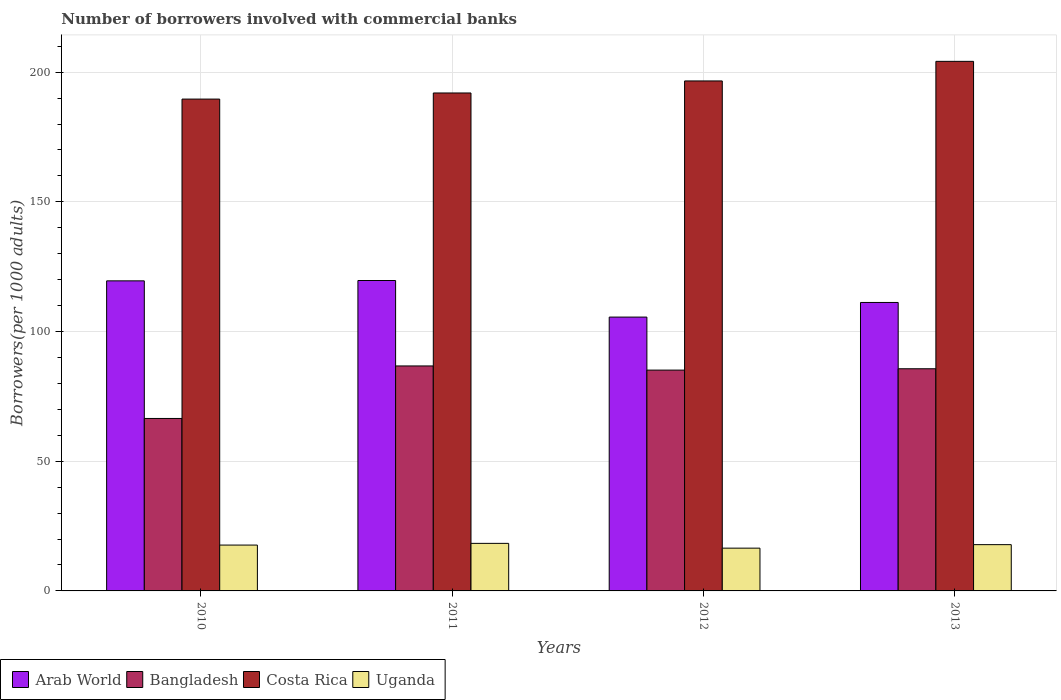How many different coloured bars are there?
Your response must be concise. 4. Are the number of bars on each tick of the X-axis equal?
Your answer should be compact. Yes. How many bars are there on the 3rd tick from the left?
Give a very brief answer. 4. How many bars are there on the 4th tick from the right?
Provide a short and direct response. 4. What is the number of borrowers involved with commercial banks in Bangladesh in 2011?
Provide a short and direct response. 86.74. Across all years, what is the maximum number of borrowers involved with commercial banks in Costa Rica?
Offer a very short reply. 204.18. Across all years, what is the minimum number of borrowers involved with commercial banks in Bangladesh?
Make the answer very short. 66.49. In which year was the number of borrowers involved with commercial banks in Arab World maximum?
Make the answer very short. 2011. What is the total number of borrowers involved with commercial banks in Uganda in the graph?
Give a very brief answer. 70.34. What is the difference between the number of borrowers involved with commercial banks in Bangladesh in 2010 and that in 2013?
Provide a short and direct response. -19.16. What is the difference between the number of borrowers involved with commercial banks in Arab World in 2012 and the number of borrowers involved with commercial banks in Uganda in 2013?
Offer a terse response. 87.74. What is the average number of borrowers involved with commercial banks in Bangladesh per year?
Offer a terse response. 81.01. In the year 2010, what is the difference between the number of borrowers involved with commercial banks in Costa Rica and number of borrowers involved with commercial banks in Arab World?
Provide a succinct answer. 70.08. In how many years, is the number of borrowers involved with commercial banks in Bangladesh greater than 110?
Give a very brief answer. 0. What is the ratio of the number of borrowers involved with commercial banks in Uganda in 2010 to that in 2011?
Your response must be concise. 0.96. What is the difference between the highest and the second highest number of borrowers involved with commercial banks in Costa Rica?
Your answer should be compact. 7.55. What is the difference between the highest and the lowest number of borrowers involved with commercial banks in Costa Rica?
Your response must be concise. 14.55. In how many years, is the number of borrowers involved with commercial banks in Uganda greater than the average number of borrowers involved with commercial banks in Uganda taken over all years?
Keep it short and to the point. 3. Is the sum of the number of borrowers involved with commercial banks in Bangladesh in 2012 and 2013 greater than the maximum number of borrowers involved with commercial banks in Costa Rica across all years?
Your answer should be very brief. No. What does the 2nd bar from the left in 2011 represents?
Make the answer very short. Bangladesh. What does the 1st bar from the right in 2010 represents?
Offer a terse response. Uganda. Is it the case that in every year, the sum of the number of borrowers involved with commercial banks in Arab World and number of borrowers involved with commercial banks in Bangladesh is greater than the number of borrowers involved with commercial banks in Uganda?
Provide a succinct answer. Yes. How many bars are there?
Offer a very short reply. 16. Are all the bars in the graph horizontal?
Provide a short and direct response. No. Are the values on the major ticks of Y-axis written in scientific E-notation?
Your response must be concise. No. Does the graph contain grids?
Offer a terse response. Yes. Where does the legend appear in the graph?
Your answer should be very brief. Bottom left. What is the title of the graph?
Make the answer very short. Number of borrowers involved with commercial banks. What is the label or title of the X-axis?
Provide a succinct answer. Years. What is the label or title of the Y-axis?
Make the answer very short. Borrowers(per 1000 adults). What is the Borrowers(per 1000 adults) in Arab World in 2010?
Ensure brevity in your answer.  119.55. What is the Borrowers(per 1000 adults) of Bangladesh in 2010?
Your response must be concise. 66.49. What is the Borrowers(per 1000 adults) in Costa Rica in 2010?
Ensure brevity in your answer.  189.63. What is the Borrowers(per 1000 adults) of Uganda in 2010?
Your response must be concise. 17.68. What is the Borrowers(per 1000 adults) in Arab World in 2011?
Give a very brief answer. 119.68. What is the Borrowers(per 1000 adults) of Bangladesh in 2011?
Keep it short and to the point. 86.74. What is the Borrowers(per 1000 adults) in Costa Rica in 2011?
Offer a very short reply. 191.98. What is the Borrowers(per 1000 adults) in Uganda in 2011?
Offer a very short reply. 18.33. What is the Borrowers(per 1000 adults) in Arab World in 2012?
Provide a short and direct response. 105.58. What is the Borrowers(per 1000 adults) of Bangladesh in 2012?
Ensure brevity in your answer.  85.13. What is the Borrowers(per 1000 adults) in Costa Rica in 2012?
Your response must be concise. 196.62. What is the Borrowers(per 1000 adults) in Uganda in 2012?
Provide a short and direct response. 16.49. What is the Borrowers(per 1000 adults) in Arab World in 2013?
Provide a succinct answer. 111.22. What is the Borrowers(per 1000 adults) in Bangladesh in 2013?
Keep it short and to the point. 85.65. What is the Borrowers(per 1000 adults) of Costa Rica in 2013?
Offer a terse response. 204.18. What is the Borrowers(per 1000 adults) of Uganda in 2013?
Make the answer very short. 17.84. Across all years, what is the maximum Borrowers(per 1000 adults) of Arab World?
Give a very brief answer. 119.68. Across all years, what is the maximum Borrowers(per 1000 adults) of Bangladesh?
Keep it short and to the point. 86.74. Across all years, what is the maximum Borrowers(per 1000 adults) in Costa Rica?
Your answer should be very brief. 204.18. Across all years, what is the maximum Borrowers(per 1000 adults) in Uganda?
Your answer should be very brief. 18.33. Across all years, what is the minimum Borrowers(per 1000 adults) in Arab World?
Provide a succinct answer. 105.58. Across all years, what is the minimum Borrowers(per 1000 adults) of Bangladesh?
Offer a very short reply. 66.49. Across all years, what is the minimum Borrowers(per 1000 adults) in Costa Rica?
Provide a short and direct response. 189.63. Across all years, what is the minimum Borrowers(per 1000 adults) of Uganda?
Offer a very short reply. 16.49. What is the total Borrowers(per 1000 adults) of Arab World in the graph?
Offer a terse response. 456.02. What is the total Borrowers(per 1000 adults) of Bangladesh in the graph?
Your response must be concise. 324.02. What is the total Borrowers(per 1000 adults) of Costa Rica in the graph?
Make the answer very short. 782.41. What is the total Borrowers(per 1000 adults) in Uganda in the graph?
Provide a short and direct response. 70.34. What is the difference between the Borrowers(per 1000 adults) of Arab World in 2010 and that in 2011?
Make the answer very short. -0.13. What is the difference between the Borrowers(per 1000 adults) in Bangladesh in 2010 and that in 2011?
Offer a terse response. -20.25. What is the difference between the Borrowers(per 1000 adults) in Costa Rica in 2010 and that in 2011?
Give a very brief answer. -2.35. What is the difference between the Borrowers(per 1000 adults) in Uganda in 2010 and that in 2011?
Provide a short and direct response. -0.66. What is the difference between the Borrowers(per 1000 adults) of Arab World in 2010 and that in 2012?
Keep it short and to the point. 13.97. What is the difference between the Borrowers(per 1000 adults) in Bangladesh in 2010 and that in 2012?
Give a very brief answer. -18.64. What is the difference between the Borrowers(per 1000 adults) in Costa Rica in 2010 and that in 2012?
Make the answer very short. -6.99. What is the difference between the Borrowers(per 1000 adults) of Uganda in 2010 and that in 2012?
Provide a short and direct response. 1.18. What is the difference between the Borrowers(per 1000 adults) in Arab World in 2010 and that in 2013?
Offer a terse response. 8.33. What is the difference between the Borrowers(per 1000 adults) of Bangladesh in 2010 and that in 2013?
Keep it short and to the point. -19.16. What is the difference between the Borrowers(per 1000 adults) in Costa Rica in 2010 and that in 2013?
Give a very brief answer. -14.55. What is the difference between the Borrowers(per 1000 adults) of Uganda in 2010 and that in 2013?
Offer a terse response. -0.17. What is the difference between the Borrowers(per 1000 adults) of Arab World in 2011 and that in 2012?
Your response must be concise. 14.1. What is the difference between the Borrowers(per 1000 adults) of Bangladesh in 2011 and that in 2012?
Your response must be concise. 1.61. What is the difference between the Borrowers(per 1000 adults) of Costa Rica in 2011 and that in 2012?
Your response must be concise. -4.64. What is the difference between the Borrowers(per 1000 adults) in Uganda in 2011 and that in 2012?
Ensure brevity in your answer.  1.84. What is the difference between the Borrowers(per 1000 adults) in Arab World in 2011 and that in 2013?
Keep it short and to the point. 8.46. What is the difference between the Borrowers(per 1000 adults) in Bangladesh in 2011 and that in 2013?
Provide a short and direct response. 1.09. What is the difference between the Borrowers(per 1000 adults) of Costa Rica in 2011 and that in 2013?
Provide a succinct answer. -12.19. What is the difference between the Borrowers(per 1000 adults) of Uganda in 2011 and that in 2013?
Provide a short and direct response. 0.49. What is the difference between the Borrowers(per 1000 adults) of Arab World in 2012 and that in 2013?
Give a very brief answer. -5.64. What is the difference between the Borrowers(per 1000 adults) of Bangladesh in 2012 and that in 2013?
Ensure brevity in your answer.  -0.52. What is the difference between the Borrowers(per 1000 adults) of Costa Rica in 2012 and that in 2013?
Provide a succinct answer. -7.55. What is the difference between the Borrowers(per 1000 adults) of Uganda in 2012 and that in 2013?
Give a very brief answer. -1.35. What is the difference between the Borrowers(per 1000 adults) in Arab World in 2010 and the Borrowers(per 1000 adults) in Bangladesh in 2011?
Your answer should be compact. 32.81. What is the difference between the Borrowers(per 1000 adults) in Arab World in 2010 and the Borrowers(per 1000 adults) in Costa Rica in 2011?
Your answer should be compact. -72.43. What is the difference between the Borrowers(per 1000 adults) in Arab World in 2010 and the Borrowers(per 1000 adults) in Uganda in 2011?
Your answer should be compact. 101.22. What is the difference between the Borrowers(per 1000 adults) of Bangladesh in 2010 and the Borrowers(per 1000 adults) of Costa Rica in 2011?
Provide a succinct answer. -125.49. What is the difference between the Borrowers(per 1000 adults) in Bangladesh in 2010 and the Borrowers(per 1000 adults) in Uganda in 2011?
Your answer should be compact. 48.16. What is the difference between the Borrowers(per 1000 adults) of Costa Rica in 2010 and the Borrowers(per 1000 adults) of Uganda in 2011?
Ensure brevity in your answer.  171.3. What is the difference between the Borrowers(per 1000 adults) of Arab World in 2010 and the Borrowers(per 1000 adults) of Bangladesh in 2012?
Provide a succinct answer. 34.41. What is the difference between the Borrowers(per 1000 adults) of Arab World in 2010 and the Borrowers(per 1000 adults) of Costa Rica in 2012?
Offer a very short reply. -77.07. What is the difference between the Borrowers(per 1000 adults) of Arab World in 2010 and the Borrowers(per 1000 adults) of Uganda in 2012?
Your answer should be compact. 103.06. What is the difference between the Borrowers(per 1000 adults) in Bangladesh in 2010 and the Borrowers(per 1000 adults) in Costa Rica in 2012?
Offer a terse response. -130.13. What is the difference between the Borrowers(per 1000 adults) in Bangladesh in 2010 and the Borrowers(per 1000 adults) in Uganda in 2012?
Provide a succinct answer. 50. What is the difference between the Borrowers(per 1000 adults) in Costa Rica in 2010 and the Borrowers(per 1000 adults) in Uganda in 2012?
Give a very brief answer. 173.14. What is the difference between the Borrowers(per 1000 adults) in Arab World in 2010 and the Borrowers(per 1000 adults) in Bangladesh in 2013?
Offer a very short reply. 33.9. What is the difference between the Borrowers(per 1000 adults) in Arab World in 2010 and the Borrowers(per 1000 adults) in Costa Rica in 2013?
Ensure brevity in your answer.  -84.63. What is the difference between the Borrowers(per 1000 adults) in Arab World in 2010 and the Borrowers(per 1000 adults) in Uganda in 2013?
Make the answer very short. 101.71. What is the difference between the Borrowers(per 1000 adults) in Bangladesh in 2010 and the Borrowers(per 1000 adults) in Costa Rica in 2013?
Make the answer very short. -137.68. What is the difference between the Borrowers(per 1000 adults) in Bangladesh in 2010 and the Borrowers(per 1000 adults) in Uganda in 2013?
Ensure brevity in your answer.  48.65. What is the difference between the Borrowers(per 1000 adults) of Costa Rica in 2010 and the Borrowers(per 1000 adults) of Uganda in 2013?
Offer a very short reply. 171.79. What is the difference between the Borrowers(per 1000 adults) in Arab World in 2011 and the Borrowers(per 1000 adults) in Bangladesh in 2012?
Offer a very short reply. 34.55. What is the difference between the Borrowers(per 1000 adults) of Arab World in 2011 and the Borrowers(per 1000 adults) of Costa Rica in 2012?
Keep it short and to the point. -76.94. What is the difference between the Borrowers(per 1000 adults) in Arab World in 2011 and the Borrowers(per 1000 adults) in Uganda in 2012?
Ensure brevity in your answer.  103.19. What is the difference between the Borrowers(per 1000 adults) of Bangladesh in 2011 and the Borrowers(per 1000 adults) of Costa Rica in 2012?
Provide a short and direct response. -109.88. What is the difference between the Borrowers(per 1000 adults) of Bangladesh in 2011 and the Borrowers(per 1000 adults) of Uganda in 2012?
Your response must be concise. 70.25. What is the difference between the Borrowers(per 1000 adults) in Costa Rica in 2011 and the Borrowers(per 1000 adults) in Uganda in 2012?
Ensure brevity in your answer.  175.49. What is the difference between the Borrowers(per 1000 adults) in Arab World in 2011 and the Borrowers(per 1000 adults) in Bangladesh in 2013?
Provide a succinct answer. 34.03. What is the difference between the Borrowers(per 1000 adults) of Arab World in 2011 and the Borrowers(per 1000 adults) of Costa Rica in 2013?
Offer a terse response. -84.5. What is the difference between the Borrowers(per 1000 adults) in Arab World in 2011 and the Borrowers(per 1000 adults) in Uganda in 2013?
Give a very brief answer. 101.84. What is the difference between the Borrowers(per 1000 adults) in Bangladesh in 2011 and the Borrowers(per 1000 adults) in Costa Rica in 2013?
Offer a terse response. -117.43. What is the difference between the Borrowers(per 1000 adults) in Bangladesh in 2011 and the Borrowers(per 1000 adults) in Uganda in 2013?
Offer a terse response. 68.9. What is the difference between the Borrowers(per 1000 adults) of Costa Rica in 2011 and the Borrowers(per 1000 adults) of Uganda in 2013?
Provide a succinct answer. 174.14. What is the difference between the Borrowers(per 1000 adults) of Arab World in 2012 and the Borrowers(per 1000 adults) of Bangladesh in 2013?
Your answer should be very brief. 19.93. What is the difference between the Borrowers(per 1000 adults) in Arab World in 2012 and the Borrowers(per 1000 adults) in Costa Rica in 2013?
Provide a short and direct response. -98.6. What is the difference between the Borrowers(per 1000 adults) of Arab World in 2012 and the Borrowers(per 1000 adults) of Uganda in 2013?
Keep it short and to the point. 87.74. What is the difference between the Borrowers(per 1000 adults) in Bangladesh in 2012 and the Borrowers(per 1000 adults) in Costa Rica in 2013?
Provide a short and direct response. -119.04. What is the difference between the Borrowers(per 1000 adults) of Bangladesh in 2012 and the Borrowers(per 1000 adults) of Uganda in 2013?
Provide a succinct answer. 67.29. What is the difference between the Borrowers(per 1000 adults) in Costa Rica in 2012 and the Borrowers(per 1000 adults) in Uganda in 2013?
Your response must be concise. 178.78. What is the average Borrowers(per 1000 adults) of Arab World per year?
Your response must be concise. 114.01. What is the average Borrowers(per 1000 adults) in Bangladesh per year?
Keep it short and to the point. 81.01. What is the average Borrowers(per 1000 adults) in Costa Rica per year?
Your answer should be compact. 195.6. What is the average Borrowers(per 1000 adults) of Uganda per year?
Make the answer very short. 17.59. In the year 2010, what is the difference between the Borrowers(per 1000 adults) of Arab World and Borrowers(per 1000 adults) of Bangladesh?
Give a very brief answer. 53.06. In the year 2010, what is the difference between the Borrowers(per 1000 adults) in Arab World and Borrowers(per 1000 adults) in Costa Rica?
Make the answer very short. -70.08. In the year 2010, what is the difference between the Borrowers(per 1000 adults) in Arab World and Borrowers(per 1000 adults) in Uganda?
Give a very brief answer. 101.87. In the year 2010, what is the difference between the Borrowers(per 1000 adults) of Bangladesh and Borrowers(per 1000 adults) of Costa Rica?
Offer a terse response. -123.14. In the year 2010, what is the difference between the Borrowers(per 1000 adults) of Bangladesh and Borrowers(per 1000 adults) of Uganda?
Your answer should be compact. 48.82. In the year 2010, what is the difference between the Borrowers(per 1000 adults) in Costa Rica and Borrowers(per 1000 adults) in Uganda?
Keep it short and to the point. 171.95. In the year 2011, what is the difference between the Borrowers(per 1000 adults) of Arab World and Borrowers(per 1000 adults) of Bangladesh?
Keep it short and to the point. 32.94. In the year 2011, what is the difference between the Borrowers(per 1000 adults) in Arab World and Borrowers(per 1000 adults) in Costa Rica?
Provide a succinct answer. -72.3. In the year 2011, what is the difference between the Borrowers(per 1000 adults) in Arab World and Borrowers(per 1000 adults) in Uganda?
Offer a terse response. 101.35. In the year 2011, what is the difference between the Borrowers(per 1000 adults) in Bangladesh and Borrowers(per 1000 adults) in Costa Rica?
Provide a succinct answer. -105.24. In the year 2011, what is the difference between the Borrowers(per 1000 adults) of Bangladesh and Borrowers(per 1000 adults) of Uganda?
Provide a short and direct response. 68.41. In the year 2011, what is the difference between the Borrowers(per 1000 adults) of Costa Rica and Borrowers(per 1000 adults) of Uganda?
Your answer should be compact. 173.65. In the year 2012, what is the difference between the Borrowers(per 1000 adults) in Arab World and Borrowers(per 1000 adults) in Bangladesh?
Your answer should be compact. 20.45. In the year 2012, what is the difference between the Borrowers(per 1000 adults) in Arab World and Borrowers(per 1000 adults) in Costa Rica?
Keep it short and to the point. -91.04. In the year 2012, what is the difference between the Borrowers(per 1000 adults) of Arab World and Borrowers(per 1000 adults) of Uganda?
Give a very brief answer. 89.09. In the year 2012, what is the difference between the Borrowers(per 1000 adults) in Bangladesh and Borrowers(per 1000 adults) in Costa Rica?
Give a very brief answer. -111.49. In the year 2012, what is the difference between the Borrowers(per 1000 adults) of Bangladesh and Borrowers(per 1000 adults) of Uganda?
Give a very brief answer. 68.64. In the year 2012, what is the difference between the Borrowers(per 1000 adults) in Costa Rica and Borrowers(per 1000 adults) in Uganda?
Offer a terse response. 180.13. In the year 2013, what is the difference between the Borrowers(per 1000 adults) in Arab World and Borrowers(per 1000 adults) in Bangladesh?
Your answer should be compact. 25.56. In the year 2013, what is the difference between the Borrowers(per 1000 adults) in Arab World and Borrowers(per 1000 adults) in Costa Rica?
Keep it short and to the point. -92.96. In the year 2013, what is the difference between the Borrowers(per 1000 adults) of Arab World and Borrowers(per 1000 adults) of Uganda?
Your answer should be very brief. 93.37. In the year 2013, what is the difference between the Borrowers(per 1000 adults) of Bangladesh and Borrowers(per 1000 adults) of Costa Rica?
Make the answer very short. -118.52. In the year 2013, what is the difference between the Borrowers(per 1000 adults) in Bangladesh and Borrowers(per 1000 adults) in Uganda?
Make the answer very short. 67.81. In the year 2013, what is the difference between the Borrowers(per 1000 adults) in Costa Rica and Borrowers(per 1000 adults) in Uganda?
Provide a succinct answer. 186.33. What is the ratio of the Borrowers(per 1000 adults) of Bangladesh in 2010 to that in 2011?
Your answer should be compact. 0.77. What is the ratio of the Borrowers(per 1000 adults) of Costa Rica in 2010 to that in 2011?
Your response must be concise. 0.99. What is the ratio of the Borrowers(per 1000 adults) of Uganda in 2010 to that in 2011?
Ensure brevity in your answer.  0.96. What is the ratio of the Borrowers(per 1000 adults) in Arab World in 2010 to that in 2012?
Give a very brief answer. 1.13. What is the ratio of the Borrowers(per 1000 adults) in Bangladesh in 2010 to that in 2012?
Give a very brief answer. 0.78. What is the ratio of the Borrowers(per 1000 adults) of Costa Rica in 2010 to that in 2012?
Ensure brevity in your answer.  0.96. What is the ratio of the Borrowers(per 1000 adults) of Uganda in 2010 to that in 2012?
Your answer should be compact. 1.07. What is the ratio of the Borrowers(per 1000 adults) in Arab World in 2010 to that in 2013?
Offer a terse response. 1.07. What is the ratio of the Borrowers(per 1000 adults) in Bangladesh in 2010 to that in 2013?
Offer a very short reply. 0.78. What is the ratio of the Borrowers(per 1000 adults) of Costa Rica in 2010 to that in 2013?
Give a very brief answer. 0.93. What is the ratio of the Borrowers(per 1000 adults) in Arab World in 2011 to that in 2012?
Give a very brief answer. 1.13. What is the ratio of the Borrowers(per 1000 adults) of Bangladesh in 2011 to that in 2012?
Provide a short and direct response. 1.02. What is the ratio of the Borrowers(per 1000 adults) in Costa Rica in 2011 to that in 2012?
Offer a very short reply. 0.98. What is the ratio of the Borrowers(per 1000 adults) of Uganda in 2011 to that in 2012?
Your response must be concise. 1.11. What is the ratio of the Borrowers(per 1000 adults) in Arab World in 2011 to that in 2013?
Keep it short and to the point. 1.08. What is the ratio of the Borrowers(per 1000 adults) in Bangladesh in 2011 to that in 2013?
Your answer should be compact. 1.01. What is the ratio of the Borrowers(per 1000 adults) in Costa Rica in 2011 to that in 2013?
Give a very brief answer. 0.94. What is the ratio of the Borrowers(per 1000 adults) in Uganda in 2011 to that in 2013?
Offer a very short reply. 1.03. What is the ratio of the Borrowers(per 1000 adults) of Arab World in 2012 to that in 2013?
Provide a short and direct response. 0.95. What is the ratio of the Borrowers(per 1000 adults) of Uganda in 2012 to that in 2013?
Keep it short and to the point. 0.92. What is the difference between the highest and the second highest Borrowers(per 1000 adults) in Arab World?
Keep it short and to the point. 0.13. What is the difference between the highest and the second highest Borrowers(per 1000 adults) of Bangladesh?
Offer a terse response. 1.09. What is the difference between the highest and the second highest Borrowers(per 1000 adults) of Costa Rica?
Your answer should be very brief. 7.55. What is the difference between the highest and the second highest Borrowers(per 1000 adults) of Uganda?
Your answer should be very brief. 0.49. What is the difference between the highest and the lowest Borrowers(per 1000 adults) of Arab World?
Offer a very short reply. 14.1. What is the difference between the highest and the lowest Borrowers(per 1000 adults) in Bangladesh?
Provide a short and direct response. 20.25. What is the difference between the highest and the lowest Borrowers(per 1000 adults) of Costa Rica?
Make the answer very short. 14.55. What is the difference between the highest and the lowest Borrowers(per 1000 adults) of Uganda?
Your answer should be compact. 1.84. 